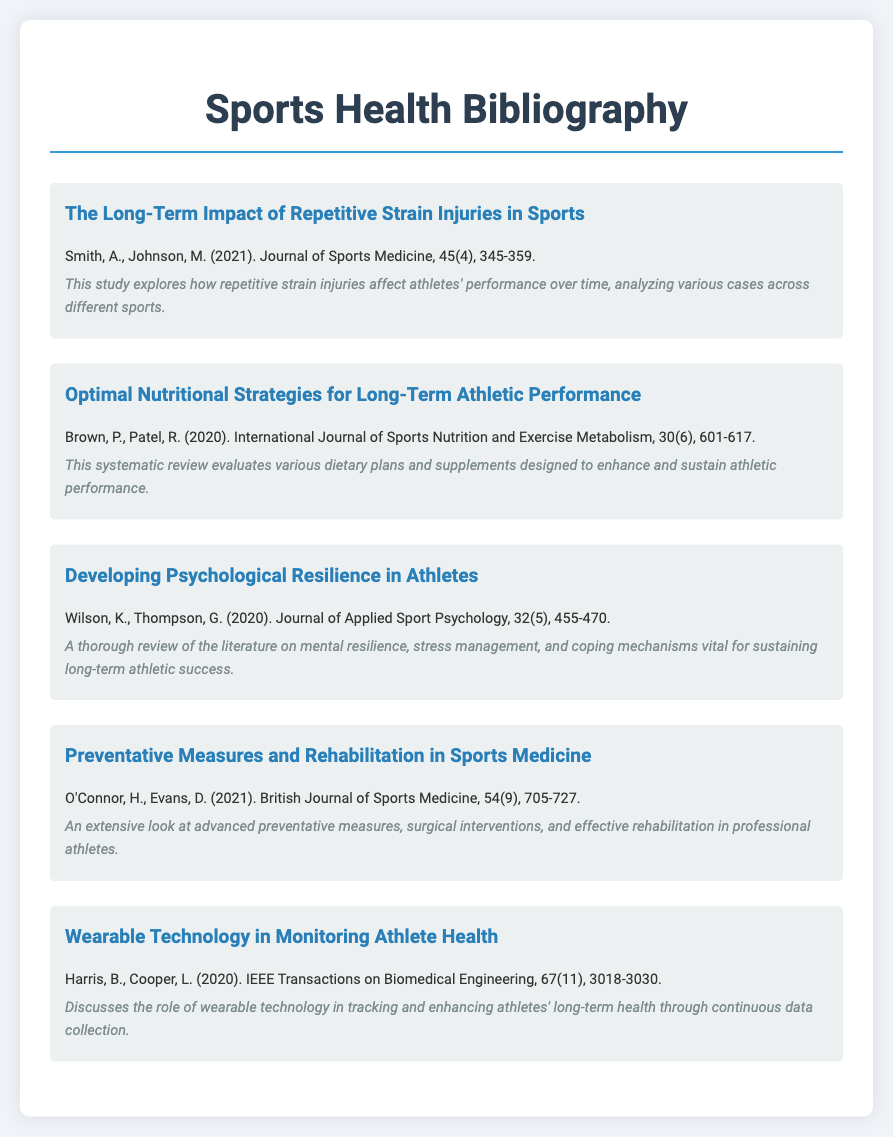What is the title of the first item in the bibliography? The title is found at the beginning of each bibliography item, showing the key topic of the study.
Answer: The Long-Term Impact of Repetitive Strain Injuries in Sports Who authored the paper on nutritional strategies? This information is listed directly after the title in each bibliography entry.
Answer: Brown, P., Patel, R In what year was the paper on developing psychological resilience published? The publication year is stated within each bibliographic entry, facilitating easy reference.
Answer: 2020 What is the journal of the last item listed? The journal name is typically included with the reference details for each study.
Answer: IEEE Transactions on Biomedical Engineering How many items are in this bibliography? The total number of items can be counted from the entries presented in the document.
Answer: Five Which study discusses wearable technology? The question relates to the specific focus of one of the listed studies.
Answer: Wearable Technology in Monitoring Athlete Health What do the authors O'Connor and Evans study? The study's focus is indicated in the title and annotated description.
Answer: Preventative Measures and Rehabilitation in Sports Medicine Which study covers the effects of dietary plans? The title and focus of the study indicate its subject matter regarding dietary strategies.
Answer: Optimal Nutritional Strategies for Long-Term Athletic Performance What volume and issue number is associated with the paper on preventative measures? The volume and issue numbers are specified in the reference to help identify the publication details.
Answer: 54(9) 